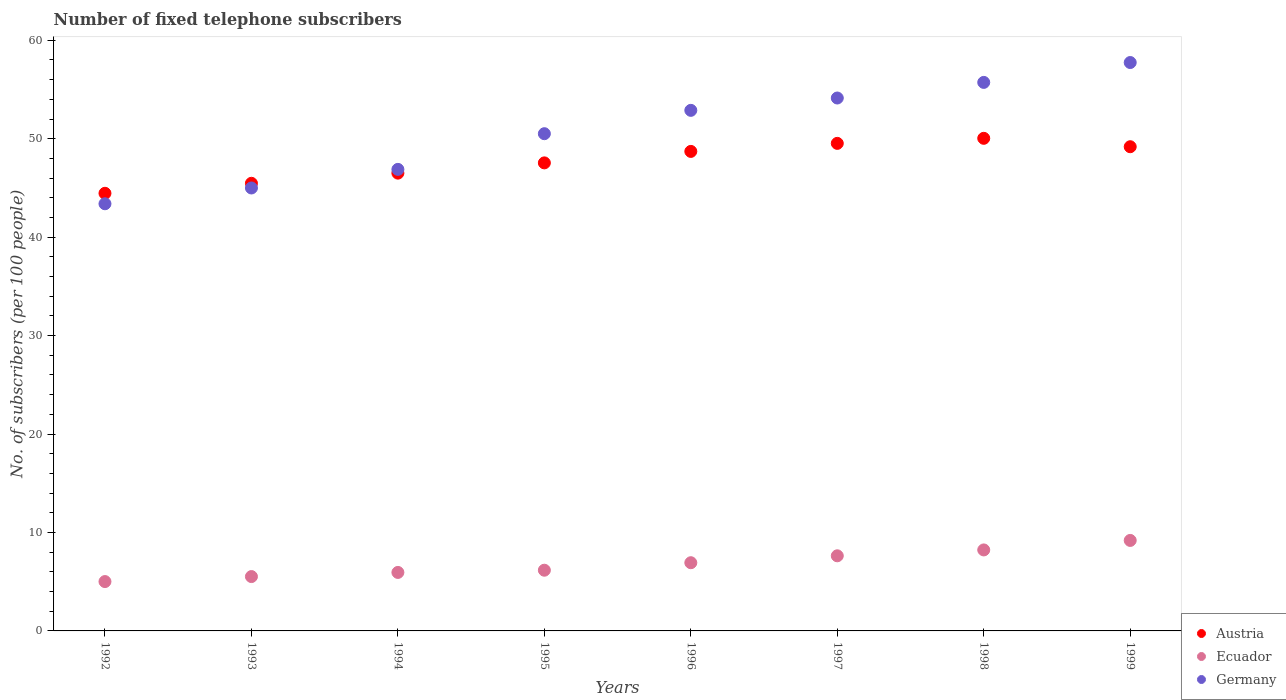How many different coloured dotlines are there?
Offer a very short reply. 3. What is the number of fixed telephone subscribers in Austria in 1995?
Your answer should be very brief. 47.55. Across all years, what is the maximum number of fixed telephone subscribers in Ecuador?
Make the answer very short. 9.19. Across all years, what is the minimum number of fixed telephone subscribers in Germany?
Offer a terse response. 43.39. In which year was the number of fixed telephone subscribers in Ecuador maximum?
Give a very brief answer. 1999. In which year was the number of fixed telephone subscribers in Austria minimum?
Your response must be concise. 1992. What is the total number of fixed telephone subscribers in Germany in the graph?
Ensure brevity in your answer.  406.28. What is the difference between the number of fixed telephone subscribers in Germany in 1993 and that in 1994?
Your response must be concise. -1.89. What is the difference between the number of fixed telephone subscribers in Germany in 1998 and the number of fixed telephone subscribers in Ecuador in 1995?
Ensure brevity in your answer.  49.56. What is the average number of fixed telephone subscribers in Austria per year?
Make the answer very short. 47.68. In the year 1993, what is the difference between the number of fixed telephone subscribers in Austria and number of fixed telephone subscribers in Germany?
Give a very brief answer. 0.48. In how many years, is the number of fixed telephone subscribers in Austria greater than 30?
Make the answer very short. 8. What is the ratio of the number of fixed telephone subscribers in Ecuador in 1996 to that in 1998?
Provide a short and direct response. 0.84. Is the difference between the number of fixed telephone subscribers in Austria in 1993 and 1997 greater than the difference between the number of fixed telephone subscribers in Germany in 1993 and 1997?
Ensure brevity in your answer.  Yes. What is the difference between the highest and the second highest number of fixed telephone subscribers in Ecuador?
Give a very brief answer. 0.96. What is the difference between the highest and the lowest number of fixed telephone subscribers in Ecuador?
Ensure brevity in your answer.  4.18. In how many years, is the number of fixed telephone subscribers in Germany greater than the average number of fixed telephone subscribers in Germany taken over all years?
Your answer should be compact. 4. Is the sum of the number of fixed telephone subscribers in Ecuador in 1996 and 1998 greater than the maximum number of fixed telephone subscribers in Germany across all years?
Provide a short and direct response. No. Is the number of fixed telephone subscribers in Germany strictly greater than the number of fixed telephone subscribers in Ecuador over the years?
Make the answer very short. Yes. How many dotlines are there?
Keep it short and to the point. 3. What is the difference between two consecutive major ticks on the Y-axis?
Your answer should be very brief. 10. Are the values on the major ticks of Y-axis written in scientific E-notation?
Your answer should be very brief. No. Does the graph contain any zero values?
Your answer should be compact. No. Where does the legend appear in the graph?
Ensure brevity in your answer.  Bottom right. What is the title of the graph?
Keep it short and to the point. Number of fixed telephone subscribers. What is the label or title of the Y-axis?
Keep it short and to the point. No. of subscribers (per 100 people). What is the No. of subscribers (per 100 people) of Austria in 1992?
Offer a terse response. 44.46. What is the No. of subscribers (per 100 people) of Ecuador in 1992?
Your answer should be very brief. 5.01. What is the No. of subscribers (per 100 people) of Germany in 1992?
Make the answer very short. 43.39. What is the No. of subscribers (per 100 people) in Austria in 1993?
Your answer should be compact. 45.47. What is the No. of subscribers (per 100 people) of Ecuador in 1993?
Offer a very short reply. 5.52. What is the No. of subscribers (per 100 people) of Germany in 1993?
Provide a short and direct response. 45. What is the No. of subscribers (per 100 people) of Austria in 1994?
Offer a very short reply. 46.51. What is the No. of subscribers (per 100 people) in Ecuador in 1994?
Provide a short and direct response. 5.94. What is the No. of subscribers (per 100 people) of Germany in 1994?
Your answer should be compact. 46.89. What is the No. of subscribers (per 100 people) in Austria in 1995?
Make the answer very short. 47.55. What is the No. of subscribers (per 100 people) of Ecuador in 1995?
Offer a very short reply. 6.17. What is the No. of subscribers (per 100 people) of Germany in 1995?
Give a very brief answer. 50.51. What is the No. of subscribers (per 100 people) in Austria in 1996?
Your answer should be very brief. 48.71. What is the No. of subscribers (per 100 people) of Ecuador in 1996?
Offer a very short reply. 6.93. What is the No. of subscribers (per 100 people) of Germany in 1996?
Your answer should be compact. 52.88. What is the No. of subscribers (per 100 people) of Austria in 1997?
Ensure brevity in your answer.  49.53. What is the No. of subscribers (per 100 people) of Ecuador in 1997?
Make the answer very short. 7.63. What is the No. of subscribers (per 100 people) in Germany in 1997?
Ensure brevity in your answer.  54.14. What is the No. of subscribers (per 100 people) in Austria in 1998?
Your answer should be very brief. 50.04. What is the No. of subscribers (per 100 people) of Ecuador in 1998?
Keep it short and to the point. 8.23. What is the No. of subscribers (per 100 people) in Germany in 1998?
Provide a succinct answer. 55.72. What is the No. of subscribers (per 100 people) of Austria in 1999?
Offer a terse response. 49.19. What is the No. of subscribers (per 100 people) of Ecuador in 1999?
Offer a very short reply. 9.19. What is the No. of subscribers (per 100 people) of Germany in 1999?
Provide a succinct answer. 57.74. Across all years, what is the maximum No. of subscribers (per 100 people) in Austria?
Your answer should be very brief. 50.04. Across all years, what is the maximum No. of subscribers (per 100 people) of Ecuador?
Provide a short and direct response. 9.19. Across all years, what is the maximum No. of subscribers (per 100 people) in Germany?
Your answer should be compact. 57.74. Across all years, what is the minimum No. of subscribers (per 100 people) in Austria?
Make the answer very short. 44.46. Across all years, what is the minimum No. of subscribers (per 100 people) in Ecuador?
Make the answer very short. 5.01. Across all years, what is the minimum No. of subscribers (per 100 people) in Germany?
Your answer should be very brief. 43.39. What is the total No. of subscribers (per 100 people) of Austria in the graph?
Provide a short and direct response. 381.46. What is the total No. of subscribers (per 100 people) of Ecuador in the graph?
Offer a very short reply. 54.62. What is the total No. of subscribers (per 100 people) of Germany in the graph?
Make the answer very short. 406.28. What is the difference between the No. of subscribers (per 100 people) in Austria in 1992 and that in 1993?
Offer a very short reply. -1.02. What is the difference between the No. of subscribers (per 100 people) of Ecuador in 1992 and that in 1993?
Your response must be concise. -0.51. What is the difference between the No. of subscribers (per 100 people) in Germany in 1992 and that in 1993?
Your response must be concise. -1.6. What is the difference between the No. of subscribers (per 100 people) in Austria in 1992 and that in 1994?
Provide a succinct answer. -2.05. What is the difference between the No. of subscribers (per 100 people) of Ecuador in 1992 and that in 1994?
Provide a succinct answer. -0.93. What is the difference between the No. of subscribers (per 100 people) of Germany in 1992 and that in 1994?
Keep it short and to the point. -3.49. What is the difference between the No. of subscribers (per 100 people) in Austria in 1992 and that in 1995?
Ensure brevity in your answer.  -3.09. What is the difference between the No. of subscribers (per 100 people) in Ecuador in 1992 and that in 1995?
Provide a succinct answer. -1.15. What is the difference between the No. of subscribers (per 100 people) of Germany in 1992 and that in 1995?
Offer a terse response. -7.12. What is the difference between the No. of subscribers (per 100 people) of Austria in 1992 and that in 1996?
Offer a terse response. -4.25. What is the difference between the No. of subscribers (per 100 people) of Ecuador in 1992 and that in 1996?
Your answer should be very brief. -1.92. What is the difference between the No. of subscribers (per 100 people) of Germany in 1992 and that in 1996?
Ensure brevity in your answer.  -9.49. What is the difference between the No. of subscribers (per 100 people) in Austria in 1992 and that in 1997?
Make the answer very short. -5.07. What is the difference between the No. of subscribers (per 100 people) of Ecuador in 1992 and that in 1997?
Your answer should be compact. -2.62. What is the difference between the No. of subscribers (per 100 people) in Germany in 1992 and that in 1997?
Offer a terse response. -10.74. What is the difference between the No. of subscribers (per 100 people) in Austria in 1992 and that in 1998?
Your answer should be compact. -5.59. What is the difference between the No. of subscribers (per 100 people) of Ecuador in 1992 and that in 1998?
Your answer should be very brief. -3.21. What is the difference between the No. of subscribers (per 100 people) of Germany in 1992 and that in 1998?
Ensure brevity in your answer.  -12.33. What is the difference between the No. of subscribers (per 100 people) in Austria in 1992 and that in 1999?
Provide a short and direct response. -4.73. What is the difference between the No. of subscribers (per 100 people) in Ecuador in 1992 and that in 1999?
Your answer should be compact. -4.18. What is the difference between the No. of subscribers (per 100 people) in Germany in 1992 and that in 1999?
Make the answer very short. -14.35. What is the difference between the No. of subscribers (per 100 people) of Austria in 1993 and that in 1994?
Provide a short and direct response. -1.03. What is the difference between the No. of subscribers (per 100 people) of Ecuador in 1993 and that in 1994?
Your answer should be compact. -0.42. What is the difference between the No. of subscribers (per 100 people) of Germany in 1993 and that in 1994?
Your response must be concise. -1.89. What is the difference between the No. of subscribers (per 100 people) in Austria in 1993 and that in 1995?
Provide a short and direct response. -2.07. What is the difference between the No. of subscribers (per 100 people) of Ecuador in 1993 and that in 1995?
Provide a succinct answer. -0.65. What is the difference between the No. of subscribers (per 100 people) of Germany in 1993 and that in 1995?
Keep it short and to the point. -5.51. What is the difference between the No. of subscribers (per 100 people) of Austria in 1993 and that in 1996?
Provide a succinct answer. -3.24. What is the difference between the No. of subscribers (per 100 people) of Ecuador in 1993 and that in 1996?
Offer a very short reply. -1.41. What is the difference between the No. of subscribers (per 100 people) of Germany in 1993 and that in 1996?
Ensure brevity in your answer.  -7.89. What is the difference between the No. of subscribers (per 100 people) of Austria in 1993 and that in 1997?
Keep it short and to the point. -4.06. What is the difference between the No. of subscribers (per 100 people) of Ecuador in 1993 and that in 1997?
Provide a succinct answer. -2.11. What is the difference between the No. of subscribers (per 100 people) in Germany in 1993 and that in 1997?
Your answer should be very brief. -9.14. What is the difference between the No. of subscribers (per 100 people) of Austria in 1993 and that in 1998?
Keep it short and to the point. -4.57. What is the difference between the No. of subscribers (per 100 people) in Ecuador in 1993 and that in 1998?
Provide a short and direct response. -2.71. What is the difference between the No. of subscribers (per 100 people) of Germany in 1993 and that in 1998?
Provide a succinct answer. -10.73. What is the difference between the No. of subscribers (per 100 people) in Austria in 1993 and that in 1999?
Give a very brief answer. -3.71. What is the difference between the No. of subscribers (per 100 people) in Ecuador in 1993 and that in 1999?
Give a very brief answer. -3.67. What is the difference between the No. of subscribers (per 100 people) of Germany in 1993 and that in 1999?
Offer a terse response. -12.74. What is the difference between the No. of subscribers (per 100 people) in Austria in 1994 and that in 1995?
Make the answer very short. -1.04. What is the difference between the No. of subscribers (per 100 people) of Ecuador in 1994 and that in 1995?
Give a very brief answer. -0.23. What is the difference between the No. of subscribers (per 100 people) in Germany in 1994 and that in 1995?
Your response must be concise. -3.62. What is the difference between the No. of subscribers (per 100 people) in Austria in 1994 and that in 1996?
Offer a terse response. -2.21. What is the difference between the No. of subscribers (per 100 people) of Ecuador in 1994 and that in 1996?
Keep it short and to the point. -0.99. What is the difference between the No. of subscribers (per 100 people) of Germany in 1994 and that in 1996?
Your answer should be very brief. -6. What is the difference between the No. of subscribers (per 100 people) in Austria in 1994 and that in 1997?
Your answer should be compact. -3.02. What is the difference between the No. of subscribers (per 100 people) in Ecuador in 1994 and that in 1997?
Give a very brief answer. -1.69. What is the difference between the No. of subscribers (per 100 people) of Germany in 1994 and that in 1997?
Make the answer very short. -7.25. What is the difference between the No. of subscribers (per 100 people) of Austria in 1994 and that in 1998?
Provide a succinct answer. -3.54. What is the difference between the No. of subscribers (per 100 people) of Ecuador in 1994 and that in 1998?
Your answer should be compact. -2.29. What is the difference between the No. of subscribers (per 100 people) of Germany in 1994 and that in 1998?
Your response must be concise. -8.84. What is the difference between the No. of subscribers (per 100 people) in Austria in 1994 and that in 1999?
Give a very brief answer. -2.68. What is the difference between the No. of subscribers (per 100 people) of Ecuador in 1994 and that in 1999?
Ensure brevity in your answer.  -3.25. What is the difference between the No. of subscribers (per 100 people) in Germany in 1994 and that in 1999?
Provide a short and direct response. -10.85. What is the difference between the No. of subscribers (per 100 people) in Austria in 1995 and that in 1996?
Ensure brevity in your answer.  -1.16. What is the difference between the No. of subscribers (per 100 people) of Ecuador in 1995 and that in 1996?
Provide a succinct answer. -0.76. What is the difference between the No. of subscribers (per 100 people) in Germany in 1995 and that in 1996?
Provide a succinct answer. -2.37. What is the difference between the No. of subscribers (per 100 people) in Austria in 1995 and that in 1997?
Provide a succinct answer. -1.98. What is the difference between the No. of subscribers (per 100 people) in Ecuador in 1995 and that in 1997?
Your answer should be compact. -1.46. What is the difference between the No. of subscribers (per 100 people) of Germany in 1995 and that in 1997?
Keep it short and to the point. -3.63. What is the difference between the No. of subscribers (per 100 people) of Austria in 1995 and that in 1998?
Give a very brief answer. -2.5. What is the difference between the No. of subscribers (per 100 people) in Ecuador in 1995 and that in 1998?
Keep it short and to the point. -2.06. What is the difference between the No. of subscribers (per 100 people) of Germany in 1995 and that in 1998?
Provide a succinct answer. -5.21. What is the difference between the No. of subscribers (per 100 people) of Austria in 1995 and that in 1999?
Make the answer very short. -1.64. What is the difference between the No. of subscribers (per 100 people) in Ecuador in 1995 and that in 1999?
Your answer should be very brief. -3.03. What is the difference between the No. of subscribers (per 100 people) of Germany in 1995 and that in 1999?
Your answer should be compact. -7.23. What is the difference between the No. of subscribers (per 100 people) of Austria in 1996 and that in 1997?
Your answer should be very brief. -0.82. What is the difference between the No. of subscribers (per 100 people) of Ecuador in 1996 and that in 1997?
Make the answer very short. -0.7. What is the difference between the No. of subscribers (per 100 people) in Germany in 1996 and that in 1997?
Provide a succinct answer. -1.25. What is the difference between the No. of subscribers (per 100 people) of Austria in 1996 and that in 1998?
Give a very brief answer. -1.33. What is the difference between the No. of subscribers (per 100 people) of Ecuador in 1996 and that in 1998?
Provide a succinct answer. -1.3. What is the difference between the No. of subscribers (per 100 people) of Germany in 1996 and that in 1998?
Keep it short and to the point. -2.84. What is the difference between the No. of subscribers (per 100 people) in Austria in 1996 and that in 1999?
Make the answer very short. -0.48. What is the difference between the No. of subscribers (per 100 people) of Ecuador in 1996 and that in 1999?
Offer a very short reply. -2.26. What is the difference between the No. of subscribers (per 100 people) of Germany in 1996 and that in 1999?
Provide a short and direct response. -4.86. What is the difference between the No. of subscribers (per 100 people) in Austria in 1997 and that in 1998?
Keep it short and to the point. -0.51. What is the difference between the No. of subscribers (per 100 people) of Ecuador in 1997 and that in 1998?
Offer a very short reply. -0.6. What is the difference between the No. of subscribers (per 100 people) in Germany in 1997 and that in 1998?
Give a very brief answer. -1.59. What is the difference between the No. of subscribers (per 100 people) in Austria in 1997 and that in 1999?
Provide a succinct answer. 0.34. What is the difference between the No. of subscribers (per 100 people) in Ecuador in 1997 and that in 1999?
Provide a succinct answer. -1.56. What is the difference between the No. of subscribers (per 100 people) of Germany in 1997 and that in 1999?
Provide a succinct answer. -3.61. What is the difference between the No. of subscribers (per 100 people) in Austria in 1998 and that in 1999?
Keep it short and to the point. 0.85. What is the difference between the No. of subscribers (per 100 people) in Ecuador in 1998 and that in 1999?
Keep it short and to the point. -0.96. What is the difference between the No. of subscribers (per 100 people) of Germany in 1998 and that in 1999?
Keep it short and to the point. -2.02. What is the difference between the No. of subscribers (per 100 people) of Austria in 1992 and the No. of subscribers (per 100 people) of Ecuador in 1993?
Your response must be concise. 38.94. What is the difference between the No. of subscribers (per 100 people) in Austria in 1992 and the No. of subscribers (per 100 people) in Germany in 1993?
Provide a short and direct response. -0.54. What is the difference between the No. of subscribers (per 100 people) in Ecuador in 1992 and the No. of subscribers (per 100 people) in Germany in 1993?
Provide a short and direct response. -39.98. What is the difference between the No. of subscribers (per 100 people) in Austria in 1992 and the No. of subscribers (per 100 people) in Ecuador in 1994?
Give a very brief answer. 38.52. What is the difference between the No. of subscribers (per 100 people) in Austria in 1992 and the No. of subscribers (per 100 people) in Germany in 1994?
Your response must be concise. -2.43. What is the difference between the No. of subscribers (per 100 people) in Ecuador in 1992 and the No. of subscribers (per 100 people) in Germany in 1994?
Ensure brevity in your answer.  -41.87. What is the difference between the No. of subscribers (per 100 people) in Austria in 1992 and the No. of subscribers (per 100 people) in Ecuador in 1995?
Your response must be concise. 38.29. What is the difference between the No. of subscribers (per 100 people) of Austria in 1992 and the No. of subscribers (per 100 people) of Germany in 1995?
Your response must be concise. -6.05. What is the difference between the No. of subscribers (per 100 people) of Ecuador in 1992 and the No. of subscribers (per 100 people) of Germany in 1995?
Give a very brief answer. -45.5. What is the difference between the No. of subscribers (per 100 people) of Austria in 1992 and the No. of subscribers (per 100 people) of Ecuador in 1996?
Offer a very short reply. 37.53. What is the difference between the No. of subscribers (per 100 people) in Austria in 1992 and the No. of subscribers (per 100 people) in Germany in 1996?
Your response must be concise. -8.43. What is the difference between the No. of subscribers (per 100 people) of Ecuador in 1992 and the No. of subscribers (per 100 people) of Germany in 1996?
Your response must be concise. -47.87. What is the difference between the No. of subscribers (per 100 people) of Austria in 1992 and the No. of subscribers (per 100 people) of Ecuador in 1997?
Your answer should be compact. 36.83. What is the difference between the No. of subscribers (per 100 people) in Austria in 1992 and the No. of subscribers (per 100 people) in Germany in 1997?
Make the answer very short. -9.68. What is the difference between the No. of subscribers (per 100 people) in Ecuador in 1992 and the No. of subscribers (per 100 people) in Germany in 1997?
Offer a terse response. -49.12. What is the difference between the No. of subscribers (per 100 people) of Austria in 1992 and the No. of subscribers (per 100 people) of Ecuador in 1998?
Offer a terse response. 36.23. What is the difference between the No. of subscribers (per 100 people) of Austria in 1992 and the No. of subscribers (per 100 people) of Germany in 1998?
Your response must be concise. -11.27. What is the difference between the No. of subscribers (per 100 people) of Ecuador in 1992 and the No. of subscribers (per 100 people) of Germany in 1998?
Offer a terse response. -50.71. What is the difference between the No. of subscribers (per 100 people) in Austria in 1992 and the No. of subscribers (per 100 people) in Ecuador in 1999?
Your response must be concise. 35.27. What is the difference between the No. of subscribers (per 100 people) of Austria in 1992 and the No. of subscribers (per 100 people) of Germany in 1999?
Your response must be concise. -13.28. What is the difference between the No. of subscribers (per 100 people) of Ecuador in 1992 and the No. of subscribers (per 100 people) of Germany in 1999?
Ensure brevity in your answer.  -52.73. What is the difference between the No. of subscribers (per 100 people) in Austria in 1993 and the No. of subscribers (per 100 people) in Ecuador in 1994?
Your response must be concise. 39.53. What is the difference between the No. of subscribers (per 100 people) of Austria in 1993 and the No. of subscribers (per 100 people) of Germany in 1994?
Make the answer very short. -1.41. What is the difference between the No. of subscribers (per 100 people) in Ecuador in 1993 and the No. of subscribers (per 100 people) in Germany in 1994?
Give a very brief answer. -41.37. What is the difference between the No. of subscribers (per 100 people) in Austria in 1993 and the No. of subscribers (per 100 people) in Ecuador in 1995?
Your answer should be compact. 39.31. What is the difference between the No. of subscribers (per 100 people) of Austria in 1993 and the No. of subscribers (per 100 people) of Germany in 1995?
Your response must be concise. -5.04. What is the difference between the No. of subscribers (per 100 people) of Ecuador in 1993 and the No. of subscribers (per 100 people) of Germany in 1995?
Make the answer very short. -44.99. What is the difference between the No. of subscribers (per 100 people) of Austria in 1993 and the No. of subscribers (per 100 people) of Ecuador in 1996?
Your answer should be compact. 38.55. What is the difference between the No. of subscribers (per 100 people) of Austria in 1993 and the No. of subscribers (per 100 people) of Germany in 1996?
Your answer should be very brief. -7.41. What is the difference between the No. of subscribers (per 100 people) in Ecuador in 1993 and the No. of subscribers (per 100 people) in Germany in 1996?
Your answer should be very brief. -47.36. What is the difference between the No. of subscribers (per 100 people) in Austria in 1993 and the No. of subscribers (per 100 people) in Ecuador in 1997?
Your response must be concise. 37.84. What is the difference between the No. of subscribers (per 100 people) of Austria in 1993 and the No. of subscribers (per 100 people) of Germany in 1997?
Provide a short and direct response. -8.66. What is the difference between the No. of subscribers (per 100 people) of Ecuador in 1993 and the No. of subscribers (per 100 people) of Germany in 1997?
Your answer should be very brief. -48.62. What is the difference between the No. of subscribers (per 100 people) of Austria in 1993 and the No. of subscribers (per 100 people) of Ecuador in 1998?
Ensure brevity in your answer.  37.25. What is the difference between the No. of subscribers (per 100 people) in Austria in 1993 and the No. of subscribers (per 100 people) in Germany in 1998?
Give a very brief answer. -10.25. What is the difference between the No. of subscribers (per 100 people) of Ecuador in 1993 and the No. of subscribers (per 100 people) of Germany in 1998?
Offer a terse response. -50.2. What is the difference between the No. of subscribers (per 100 people) in Austria in 1993 and the No. of subscribers (per 100 people) in Ecuador in 1999?
Give a very brief answer. 36.28. What is the difference between the No. of subscribers (per 100 people) of Austria in 1993 and the No. of subscribers (per 100 people) of Germany in 1999?
Your response must be concise. -12.27. What is the difference between the No. of subscribers (per 100 people) of Ecuador in 1993 and the No. of subscribers (per 100 people) of Germany in 1999?
Offer a terse response. -52.22. What is the difference between the No. of subscribers (per 100 people) of Austria in 1994 and the No. of subscribers (per 100 people) of Ecuador in 1995?
Your answer should be very brief. 40.34. What is the difference between the No. of subscribers (per 100 people) of Austria in 1994 and the No. of subscribers (per 100 people) of Germany in 1995?
Give a very brief answer. -4.01. What is the difference between the No. of subscribers (per 100 people) of Ecuador in 1994 and the No. of subscribers (per 100 people) of Germany in 1995?
Your response must be concise. -44.57. What is the difference between the No. of subscribers (per 100 people) of Austria in 1994 and the No. of subscribers (per 100 people) of Ecuador in 1996?
Provide a succinct answer. 39.58. What is the difference between the No. of subscribers (per 100 people) of Austria in 1994 and the No. of subscribers (per 100 people) of Germany in 1996?
Your answer should be very brief. -6.38. What is the difference between the No. of subscribers (per 100 people) of Ecuador in 1994 and the No. of subscribers (per 100 people) of Germany in 1996?
Provide a succinct answer. -46.94. What is the difference between the No. of subscribers (per 100 people) of Austria in 1994 and the No. of subscribers (per 100 people) of Ecuador in 1997?
Provide a succinct answer. 38.88. What is the difference between the No. of subscribers (per 100 people) in Austria in 1994 and the No. of subscribers (per 100 people) in Germany in 1997?
Your response must be concise. -7.63. What is the difference between the No. of subscribers (per 100 people) in Ecuador in 1994 and the No. of subscribers (per 100 people) in Germany in 1997?
Make the answer very short. -48.2. What is the difference between the No. of subscribers (per 100 people) of Austria in 1994 and the No. of subscribers (per 100 people) of Ecuador in 1998?
Keep it short and to the point. 38.28. What is the difference between the No. of subscribers (per 100 people) in Austria in 1994 and the No. of subscribers (per 100 people) in Germany in 1998?
Keep it short and to the point. -9.22. What is the difference between the No. of subscribers (per 100 people) of Ecuador in 1994 and the No. of subscribers (per 100 people) of Germany in 1998?
Your answer should be compact. -49.78. What is the difference between the No. of subscribers (per 100 people) of Austria in 1994 and the No. of subscribers (per 100 people) of Ecuador in 1999?
Your answer should be compact. 37.31. What is the difference between the No. of subscribers (per 100 people) in Austria in 1994 and the No. of subscribers (per 100 people) in Germany in 1999?
Offer a terse response. -11.24. What is the difference between the No. of subscribers (per 100 people) in Ecuador in 1994 and the No. of subscribers (per 100 people) in Germany in 1999?
Ensure brevity in your answer.  -51.8. What is the difference between the No. of subscribers (per 100 people) in Austria in 1995 and the No. of subscribers (per 100 people) in Ecuador in 1996?
Provide a short and direct response. 40.62. What is the difference between the No. of subscribers (per 100 people) of Austria in 1995 and the No. of subscribers (per 100 people) of Germany in 1996?
Make the answer very short. -5.34. What is the difference between the No. of subscribers (per 100 people) of Ecuador in 1995 and the No. of subscribers (per 100 people) of Germany in 1996?
Give a very brief answer. -46.72. What is the difference between the No. of subscribers (per 100 people) in Austria in 1995 and the No. of subscribers (per 100 people) in Ecuador in 1997?
Provide a succinct answer. 39.92. What is the difference between the No. of subscribers (per 100 people) in Austria in 1995 and the No. of subscribers (per 100 people) in Germany in 1997?
Keep it short and to the point. -6.59. What is the difference between the No. of subscribers (per 100 people) in Ecuador in 1995 and the No. of subscribers (per 100 people) in Germany in 1997?
Your answer should be very brief. -47.97. What is the difference between the No. of subscribers (per 100 people) in Austria in 1995 and the No. of subscribers (per 100 people) in Ecuador in 1998?
Ensure brevity in your answer.  39.32. What is the difference between the No. of subscribers (per 100 people) in Austria in 1995 and the No. of subscribers (per 100 people) in Germany in 1998?
Provide a succinct answer. -8.18. What is the difference between the No. of subscribers (per 100 people) in Ecuador in 1995 and the No. of subscribers (per 100 people) in Germany in 1998?
Keep it short and to the point. -49.56. What is the difference between the No. of subscribers (per 100 people) of Austria in 1995 and the No. of subscribers (per 100 people) of Ecuador in 1999?
Give a very brief answer. 38.36. What is the difference between the No. of subscribers (per 100 people) in Austria in 1995 and the No. of subscribers (per 100 people) in Germany in 1999?
Provide a short and direct response. -10.19. What is the difference between the No. of subscribers (per 100 people) in Ecuador in 1995 and the No. of subscribers (per 100 people) in Germany in 1999?
Your response must be concise. -51.58. What is the difference between the No. of subscribers (per 100 people) in Austria in 1996 and the No. of subscribers (per 100 people) in Ecuador in 1997?
Ensure brevity in your answer.  41.08. What is the difference between the No. of subscribers (per 100 people) in Austria in 1996 and the No. of subscribers (per 100 people) in Germany in 1997?
Keep it short and to the point. -5.42. What is the difference between the No. of subscribers (per 100 people) in Ecuador in 1996 and the No. of subscribers (per 100 people) in Germany in 1997?
Offer a very short reply. -47.21. What is the difference between the No. of subscribers (per 100 people) of Austria in 1996 and the No. of subscribers (per 100 people) of Ecuador in 1998?
Your answer should be compact. 40.49. What is the difference between the No. of subscribers (per 100 people) in Austria in 1996 and the No. of subscribers (per 100 people) in Germany in 1998?
Keep it short and to the point. -7.01. What is the difference between the No. of subscribers (per 100 people) of Ecuador in 1996 and the No. of subscribers (per 100 people) of Germany in 1998?
Ensure brevity in your answer.  -48.8. What is the difference between the No. of subscribers (per 100 people) of Austria in 1996 and the No. of subscribers (per 100 people) of Ecuador in 1999?
Ensure brevity in your answer.  39.52. What is the difference between the No. of subscribers (per 100 people) of Austria in 1996 and the No. of subscribers (per 100 people) of Germany in 1999?
Provide a succinct answer. -9.03. What is the difference between the No. of subscribers (per 100 people) in Ecuador in 1996 and the No. of subscribers (per 100 people) in Germany in 1999?
Make the answer very short. -50.81. What is the difference between the No. of subscribers (per 100 people) of Austria in 1997 and the No. of subscribers (per 100 people) of Ecuador in 1998?
Keep it short and to the point. 41.3. What is the difference between the No. of subscribers (per 100 people) in Austria in 1997 and the No. of subscribers (per 100 people) in Germany in 1998?
Keep it short and to the point. -6.19. What is the difference between the No. of subscribers (per 100 people) of Ecuador in 1997 and the No. of subscribers (per 100 people) of Germany in 1998?
Provide a short and direct response. -48.09. What is the difference between the No. of subscribers (per 100 people) in Austria in 1997 and the No. of subscribers (per 100 people) in Ecuador in 1999?
Make the answer very short. 40.34. What is the difference between the No. of subscribers (per 100 people) in Austria in 1997 and the No. of subscribers (per 100 people) in Germany in 1999?
Keep it short and to the point. -8.21. What is the difference between the No. of subscribers (per 100 people) in Ecuador in 1997 and the No. of subscribers (per 100 people) in Germany in 1999?
Your answer should be compact. -50.11. What is the difference between the No. of subscribers (per 100 people) of Austria in 1998 and the No. of subscribers (per 100 people) of Ecuador in 1999?
Your answer should be compact. 40.85. What is the difference between the No. of subscribers (per 100 people) of Austria in 1998 and the No. of subscribers (per 100 people) of Germany in 1999?
Keep it short and to the point. -7.7. What is the difference between the No. of subscribers (per 100 people) of Ecuador in 1998 and the No. of subscribers (per 100 people) of Germany in 1999?
Provide a succinct answer. -49.51. What is the average No. of subscribers (per 100 people) in Austria per year?
Your answer should be very brief. 47.68. What is the average No. of subscribers (per 100 people) of Ecuador per year?
Your answer should be very brief. 6.83. What is the average No. of subscribers (per 100 people) in Germany per year?
Your answer should be compact. 50.79. In the year 1992, what is the difference between the No. of subscribers (per 100 people) in Austria and No. of subscribers (per 100 people) in Ecuador?
Keep it short and to the point. 39.44. In the year 1992, what is the difference between the No. of subscribers (per 100 people) of Austria and No. of subscribers (per 100 people) of Germany?
Offer a terse response. 1.06. In the year 1992, what is the difference between the No. of subscribers (per 100 people) in Ecuador and No. of subscribers (per 100 people) in Germany?
Your answer should be very brief. -38.38. In the year 1993, what is the difference between the No. of subscribers (per 100 people) in Austria and No. of subscribers (per 100 people) in Ecuador?
Make the answer very short. 39.95. In the year 1993, what is the difference between the No. of subscribers (per 100 people) of Austria and No. of subscribers (per 100 people) of Germany?
Ensure brevity in your answer.  0.48. In the year 1993, what is the difference between the No. of subscribers (per 100 people) in Ecuador and No. of subscribers (per 100 people) in Germany?
Ensure brevity in your answer.  -39.48. In the year 1994, what is the difference between the No. of subscribers (per 100 people) in Austria and No. of subscribers (per 100 people) in Ecuador?
Make the answer very short. 40.56. In the year 1994, what is the difference between the No. of subscribers (per 100 people) in Austria and No. of subscribers (per 100 people) in Germany?
Your response must be concise. -0.38. In the year 1994, what is the difference between the No. of subscribers (per 100 people) of Ecuador and No. of subscribers (per 100 people) of Germany?
Offer a terse response. -40.95. In the year 1995, what is the difference between the No. of subscribers (per 100 people) in Austria and No. of subscribers (per 100 people) in Ecuador?
Provide a short and direct response. 41.38. In the year 1995, what is the difference between the No. of subscribers (per 100 people) in Austria and No. of subscribers (per 100 people) in Germany?
Give a very brief answer. -2.96. In the year 1995, what is the difference between the No. of subscribers (per 100 people) in Ecuador and No. of subscribers (per 100 people) in Germany?
Offer a terse response. -44.34. In the year 1996, what is the difference between the No. of subscribers (per 100 people) in Austria and No. of subscribers (per 100 people) in Ecuador?
Your answer should be compact. 41.78. In the year 1996, what is the difference between the No. of subscribers (per 100 people) in Austria and No. of subscribers (per 100 people) in Germany?
Make the answer very short. -4.17. In the year 1996, what is the difference between the No. of subscribers (per 100 people) of Ecuador and No. of subscribers (per 100 people) of Germany?
Provide a short and direct response. -45.96. In the year 1997, what is the difference between the No. of subscribers (per 100 people) of Austria and No. of subscribers (per 100 people) of Ecuador?
Your answer should be very brief. 41.9. In the year 1997, what is the difference between the No. of subscribers (per 100 people) of Austria and No. of subscribers (per 100 people) of Germany?
Offer a terse response. -4.61. In the year 1997, what is the difference between the No. of subscribers (per 100 people) in Ecuador and No. of subscribers (per 100 people) in Germany?
Your answer should be compact. -46.51. In the year 1998, what is the difference between the No. of subscribers (per 100 people) in Austria and No. of subscribers (per 100 people) in Ecuador?
Offer a terse response. 41.82. In the year 1998, what is the difference between the No. of subscribers (per 100 people) in Austria and No. of subscribers (per 100 people) in Germany?
Ensure brevity in your answer.  -5.68. In the year 1998, what is the difference between the No. of subscribers (per 100 people) in Ecuador and No. of subscribers (per 100 people) in Germany?
Provide a succinct answer. -47.5. In the year 1999, what is the difference between the No. of subscribers (per 100 people) in Austria and No. of subscribers (per 100 people) in Ecuador?
Your response must be concise. 40. In the year 1999, what is the difference between the No. of subscribers (per 100 people) in Austria and No. of subscribers (per 100 people) in Germany?
Your answer should be very brief. -8.55. In the year 1999, what is the difference between the No. of subscribers (per 100 people) in Ecuador and No. of subscribers (per 100 people) in Germany?
Keep it short and to the point. -48.55. What is the ratio of the No. of subscribers (per 100 people) of Austria in 1992 to that in 1993?
Give a very brief answer. 0.98. What is the ratio of the No. of subscribers (per 100 people) of Ecuador in 1992 to that in 1993?
Your response must be concise. 0.91. What is the ratio of the No. of subscribers (per 100 people) in Germany in 1992 to that in 1993?
Provide a short and direct response. 0.96. What is the ratio of the No. of subscribers (per 100 people) in Austria in 1992 to that in 1994?
Give a very brief answer. 0.96. What is the ratio of the No. of subscribers (per 100 people) in Ecuador in 1992 to that in 1994?
Provide a short and direct response. 0.84. What is the ratio of the No. of subscribers (per 100 people) of Germany in 1992 to that in 1994?
Ensure brevity in your answer.  0.93. What is the ratio of the No. of subscribers (per 100 people) in Austria in 1992 to that in 1995?
Offer a terse response. 0.94. What is the ratio of the No. of subscribers (per 100 people) in Ecuador in 1992 to that in 1995?
Offer a terse response. 0.81. What is the ratio of the No. of subscribers (per 100 people) of Germany in 1992 to that in 1995?
Ensure brevity in your answer.  0.86. What is the ratio of the No. of subscribers (per 100 people) in Austria in 1992 to that in 1996?
Provide a short and direct response. 0.91. What is the ratio of the No. of subscribers (per 100 people) of Ecuador in 1992 to that in 1996?
Offer a terse response. 0.72. What is the ratio of the No. of subscribers (per 100 people) of Germany in 1992 to that in 1996?
Ensure brevity in your answer.  0.82. What is the ratio of the No. of subscribers (per 100 people) in Austria in 1992 to that in 1997?
Your response must be concise. 0.9. What is the ratio of the No. of subscribers (per 100 people) in Ecuador in 1992 to that in 1997?
Offer a terse response. 0.66. What is the ratio of the No. of subscribers (per 100 people) in Germany in 1992 to that in 1997?
Ensure brevity in your answer.  0.8. What is the ratio of the No. of subscribers (per 100 people) of Austria in 1992 to that in 1998?
Keep it short and to the point. 0.89. What is the ratio of the No. of subscribers (per 100 people) of Ecuador in 1992 to that in 1998?
Keep it short and to the point. 0.61. What is the ratio of the No. of subscribers (per 100 people) in Germany in 1992 to that in 1998?
Keep it short and to the point. 0.78. What is the ratio of the No. of subscribers (per 100 people) of Austria in 1992 to that in 1999?
Offer a very short reply. 0.9. What is the ratio of the No. of subscribers (per 100 people) of Ecuador in 1992 to that in 1999?
Offer a terse response. 0.55. What is the ratio of the No. of subscribers (per 100 people) of Germany in 1992 to that in 1999?
Give a very brief answer. 0.75. What is the ratio of the No. of subscribers (per 100 people) in Austria in 1993 to that in 1994?
Make the answer very short. 0.98. What is the ratio of the No. of subscribers (per 100 people) of Ecuador in 1993 to that in 1994?
Give a very brief answer. 0.93. What is the ratio of the No. of subscribers (per 100 people) in Germany in 1993 to that in 1994?
Make the answer very short. 0.96. What is the ratio of the No. of subscribers (per 100 people) of Austria in 1993 to that in 1995?
Offer a terse response. 0.96. What is the ratio of the No. of subscribers (per 100 people) of Ecuador in 1993 to that in 1995?
Offer a terse response. 0.9. What is the ratio of the No. of subscribers (per 100 people) in Germany in 1993 to that in 1995?
Your answer should be compact. 0.89. What is the ratio of the No. of subscribers (per 100 people) in Austria in 1993 to that in 1996?
Keep it short and to the point. 0.93. What is the ratio of the No. of subscribers (per 100 people) of Ecuador in 1993 to that in 1996?
Your answer should be compact. 0.8. What is the ratio of the No. of subscribers (per 100 people) of Germany in 1993 to that in 1996?
Provide a succinct answer. 0.85. What is the ratio of the No. of subscribers (per 100 people) in Austria in 1993 to that in 1997?
Ensure brevity in your answer.  0.92. What is the ratio of the No. of subscribers (per 100 people) of Ecuador in 1993 to that in 1997?
Provide a short and direct response. 0.72. What is the ratio of the No. of subscribers (per 100 people) in Germany in 1993 to that in 1997?
Make the answer very short. 0.83. What is the ratio of the No. of subscribers (per 100 people) in Austria in 1993 to that in 1998?
Your answer should be very brief. 0.91. What is the ratio of the No. of subscribers (per 100 people) in Ecuador in 1993 to that in 1998?
Provide a short and direct response. 0.67. What is the ratio of the No. of subscribers (per 100 people) in Germany in 1993 to that in 1998?
Offer a terse response. 0.81. What is the ratio of the No. of subscribers (per 100 people) in Austria in 1993 to that in 1999?
Provide a short and direct response. 0.92. What is the ratio of the No. of subscribers (per 100 people) of Ecuador in 1993 to that in 1999?
Provide a succinct answer. 0.6. What is the ratio of the No. of subscribers (per 100 people) of Germany in 1993 to that in 1999?
Provide a succinct answer. 0.78. What is the ratio of the No. of subscribers (per 100 people) of Austria in 1994 to that in 1995?
Provide a short and direct response. 0.98. What is the ratio of the No. of subscribers (per 100 people) in Ecuador in 1994 to that in 1995?
Offer a terse response. 0.96. What is the ratio of the No. of subscribers (per 100 people) in Germany in 1994 to that in 1995?
Your answer should be very brief. 0.93. What is the ratio of the No. of subscribers (per 100 people) in Austria in 1994 to that in 1996?
Provide a short and direct response. 0.95. What is the ratio of the No. of subscribers (per 100 people) in Ecuador in 1994 to that in 1996?
Your response must be concise. 0.86. What is the ratio of the No. of subscribers (per 100 people) of Germany in 1994 to that in 1996?
Your response must be concise. 0.89. What is the ratio of the No. of subscribers (per 100 people) in Austria in 1994 to that in 1997?
Give a very brief answer. 0.94. What is the ratio of the No. of subscribers (per 100 people) in Ecuador in 1994 to that in 1997?
Keep it short and to the point. 0.78. What is the ratio of the No. of subscribers (per 100 people) in Germany in 1994 to that in 1997?
Offer a very short reply. 0.87. What is the ratio of the No. of subscribers (per 100 people) of Austria in 1994 to that in 1998?
Your answer should be very brief. 0.93. What is the ratio of the No. of subscribers (per 100 people) in Ecuador in 1994 to that in 1998?
Your answer should be very brief. 0.72. What is the ratio of the No. of subscribers (per 100 people) in Germany in 1994 to that in 1998?
Offer a very short reply. 0.84. What is the ratio of the No. of subscribers (per 100 people) in Austria in 1994 to that in 1999?
Your answer should be compact. 0.95. What is the ratio of the No. of subscribers (per 100 people) of Ecuador in 1994 to that in 1999?
Offer a terse response. 0.65. What is the ratio of the No. of subscribers (per 100 people) of Germany in 1994 to that in 1999?
Provide a succinct answer. 0.81. What is the ratio of the No. of subscribers (per 100 people) in Austria in 1995 to that in 1996?
Offer a very short reply. 0.98. What is the ratio of the No. of subscribers (per 100 people) of Ecuador in 1995 to that in 1996?
Your answer should be very brief. 0.89. What is the ratio of the No. of subscribers (per 100 people) in Germany in 1995 to that in 1996?
Ensure brevity in your answer.  0.96. What is the ratio of the No. of subscribers (per 100 people) of Ecuador in 1995 to that in 1997?
Keep it short and to the point. 0.81. What is the ratio of the No. of subscribers (per 100 people) in Germany in 1995 to that in 1997?
Your response must be concise. 0.93. What is the ratio of the No. of subscribers (per 100 people) in Austria in 1995 to that in 1998?
Give a very brief answer. 0.95. What is the ratio of the No. of subscribers (per 100 people) in Ecuador in 1995 to that in 1998?
Offer a terse response. 0.75. What is the ratio of the No. of subscribers (per 100 people) in Germany in 1995 to that in 1998?
Provide a succinct answer. 0.91. What is the ratio of the No. of subscribers (per 100 people) of Austria in 1995 to that in 1999?
Provide a short and direct response. 0.97. What is the ratio of the No. of subscribers (per 100 people) in Ecuador in 1995 to that in 1999?
Your response must be concise. 0.67. What is the ratio of the No. of subscribers (per 100 people) in Germany in 1995 to that in 1999?
Keep it short and to the point. 0.87. What is the ratio of the No. of subscribers (per 100 people) of Austria in 1996 to that in 1997?
Your answer should be very brief. 0.98. What is the ratio of the No. of subscribers (per 100 people) in Ecuador in 1996 to that in 1997?
Your answer should be compact. 0.91. What is the ratio of the No. of subscribers (per 100 people) in Germany in 1996 to that in 1997?
Keep it short and to the point. 0.98. What is the ratio of the No. of subscribers (per 100 people) in Austria in 1996 to that in 1998?
Give a very brief answer. 0.97. What is the ratio of the No. of subscribers (per 100 people) in Ecuador in 1996 to that in 1998?
Your response must be concise. 0.84. What is the ratio of the No. of subscribers (per 100 people) in Germany in 1996 to that in 1998?
Your answer should be compact. 0.95. What is the ratio of the No. of subscribers (per 100 people) in Austria in 1996 to that in 1999?
Provide a succinct answer. 0.99. What is the ratio of the No. of subscribers (per 100 people) in Ecuador in 1996 to that in 1999?
Your answer should be compact. 0.75. What is the ratio of the No. of subscribers (per 100 people) of Germany in 1996 to that in 1999?
Give a very brief answer. 0.92. What is the ratio of the No. of subscribers (per 100 people) of Ecuador in 1997 to that in 1998?
Offer a terse response. 0.93. What is the ratio of the No. of subscribers (per 100 people) of Germany in 1997 to that in 1998?
Give a very brief answer. 0.97. What is the ratio of the No. of subscribers (per 100 people) of Ecuador in 1997 to that in 1999?
Ensure brevity in your answer.  0.83. What is the ratio of the No. of subscribers (per 100 people) of Germany in 1997 to that in 1999?
Provide a succinct answer. 0.94. What is the ratio of the No. of subscribers (per 100 people) in Austria in 1998 to that in 1999?
Your answer should be very brief. 1.02. What is the ratio of the No. of subscribers (per 100 people) of Ecuador in 1998 to that in 1999?
Keep it short and to the point. 0.9. What is the difference between the highest and the second highest No. of subscribers (per 100 people) in Austria?
Provide a succinct answer. 0.51. What is the difference between the highest and the second highest No. of subscribers (per 100 people) in Ecuador?
Provide a succinct answer. 0.96. What is the difference between the highest and the second highest No. of subscribers (per 100 people) of Germany?
Provide a succinct answer. 2.02. What is the difference between the highest and the lowest No. of subscribers (per 100 people) of Austria?
Ensure brevity in your answer.  5.59. What is the difference between the highest and the lowest No. of subscribers (per 100 people) of Ecuador?
Provide a short and direct response. 4.18. What is the difference between the highest and the lowest No. of subscribers (per 100 people) of Germany?
Provide a short and direct response. 14.35. 